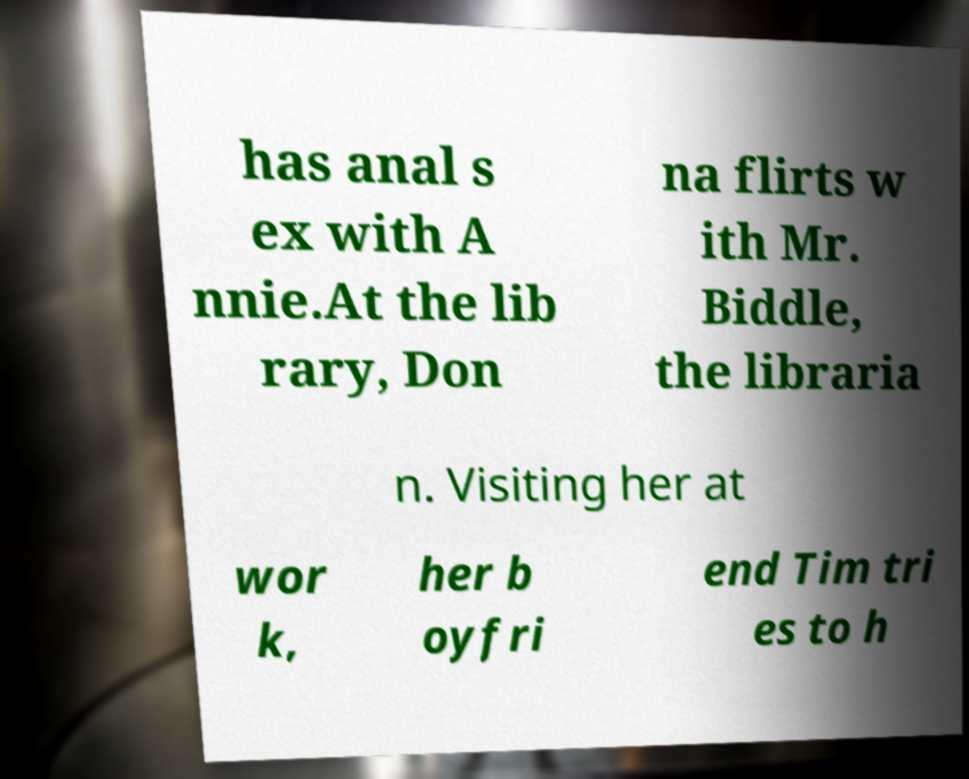Please read and relay the text visible in this image. What does it say? has anal s ex with A nnie.At the lib rary, Don na flirts w ith Mr. Biddle, the libraria n. Visiting her at wor k, her b oyfri end Tim tri es to h 